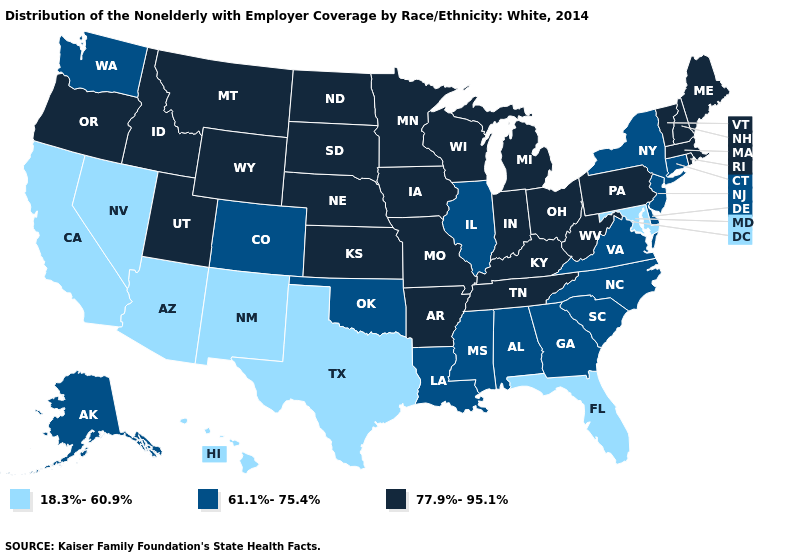What is the value of Rhode Island?
Give a very brief answer. 77.9%-95.1%. Name the states that have a value in the range 77.9%-95.1%?
Write a very short answer. Arkansas, Idaho, Indiana, Iowa, Kansas, Kentucky, Maine, Massachusetts, Michigan, Minnesota, Missouri, Montana, Nebraska, New Hampshire, North Dakota, Ohio, Oregon, Pennsylvania, Rhode Island, South Dakota, Tennessee, Utah, Vermont, West Virginia, Wisconsin, Wyoming. What is the value of Delaware?
Be succinct. 61.1%-75.4%. Name the states that have a value in the range 18.3%-60.9%?
Be succinct. Arizona, California, Florida, Hawaii, Maryland, Nevada, New Mexico, Texas. What is the value of Arizona?
Quick response, please. 18.3%-60.9%. Name the states that have a value in the range 61.1%-75.4%?
Keep it brief. Alabama, Alaska, Colorado, Connecticut, Delaware, Georgia, Illinois, Louisiana, Mississippi, New Jersey, New York, North Carolina, Oklahoma, South Carolina, Virginia, Washington. Does Arizona have the lowest value in the USA?
Answer briefly. Yes. Name the states that have a value in the range 77.9%-95.1%?
Write a very short answer. Arkansas, Idaho, Indiana, Iowa, Kansas, Kentucky, Maine, Massachusetts, Michigan, Minnesota, Missouri, Montana, Nebraska, New Hampshire, North Dakota, Ohio, Oregon, Pennsylvania, Rhode Island, South Dakota, Tennessee, Utah, Vermont, West Virginia, Wisconsin, Wyoming. Name the states that have a value in the range 77.9%-95.1%?
Keep it brief. Arkansas, Idaho, Indiana, Iowa, Kansas, Kentucky, Maine, Massachusetts, Michigan, Minnesota, Missouri, Montana, Nebraska, New Hampshire, North Dakota, Ohio, Oregon, Pennsylvania, Rhode Island, South Dakota, Tennessee, Utah, Vermont, West Virginia, Wisconsin, Wyoming. Name the states that have a value in the range 18.3%-60.9%?
Write a very short answer. Arizona, California, Florida, Hawaii, Maryland, Nevada, New Mexico, Texas. What is the highest value in states that border Alabama?
Answer briefly. 77.9%-95.1%. Is the legend a continuous bar?
Write a very short answer. No. What is the value of Vermont?
Quick response, please. 77.9%-95.1%. What is the value of Tennessee?
Answer briefly. 77.9%-95.1%. What is the value of Kentucky?
Concise answer only. 77.9%-95.1%. 